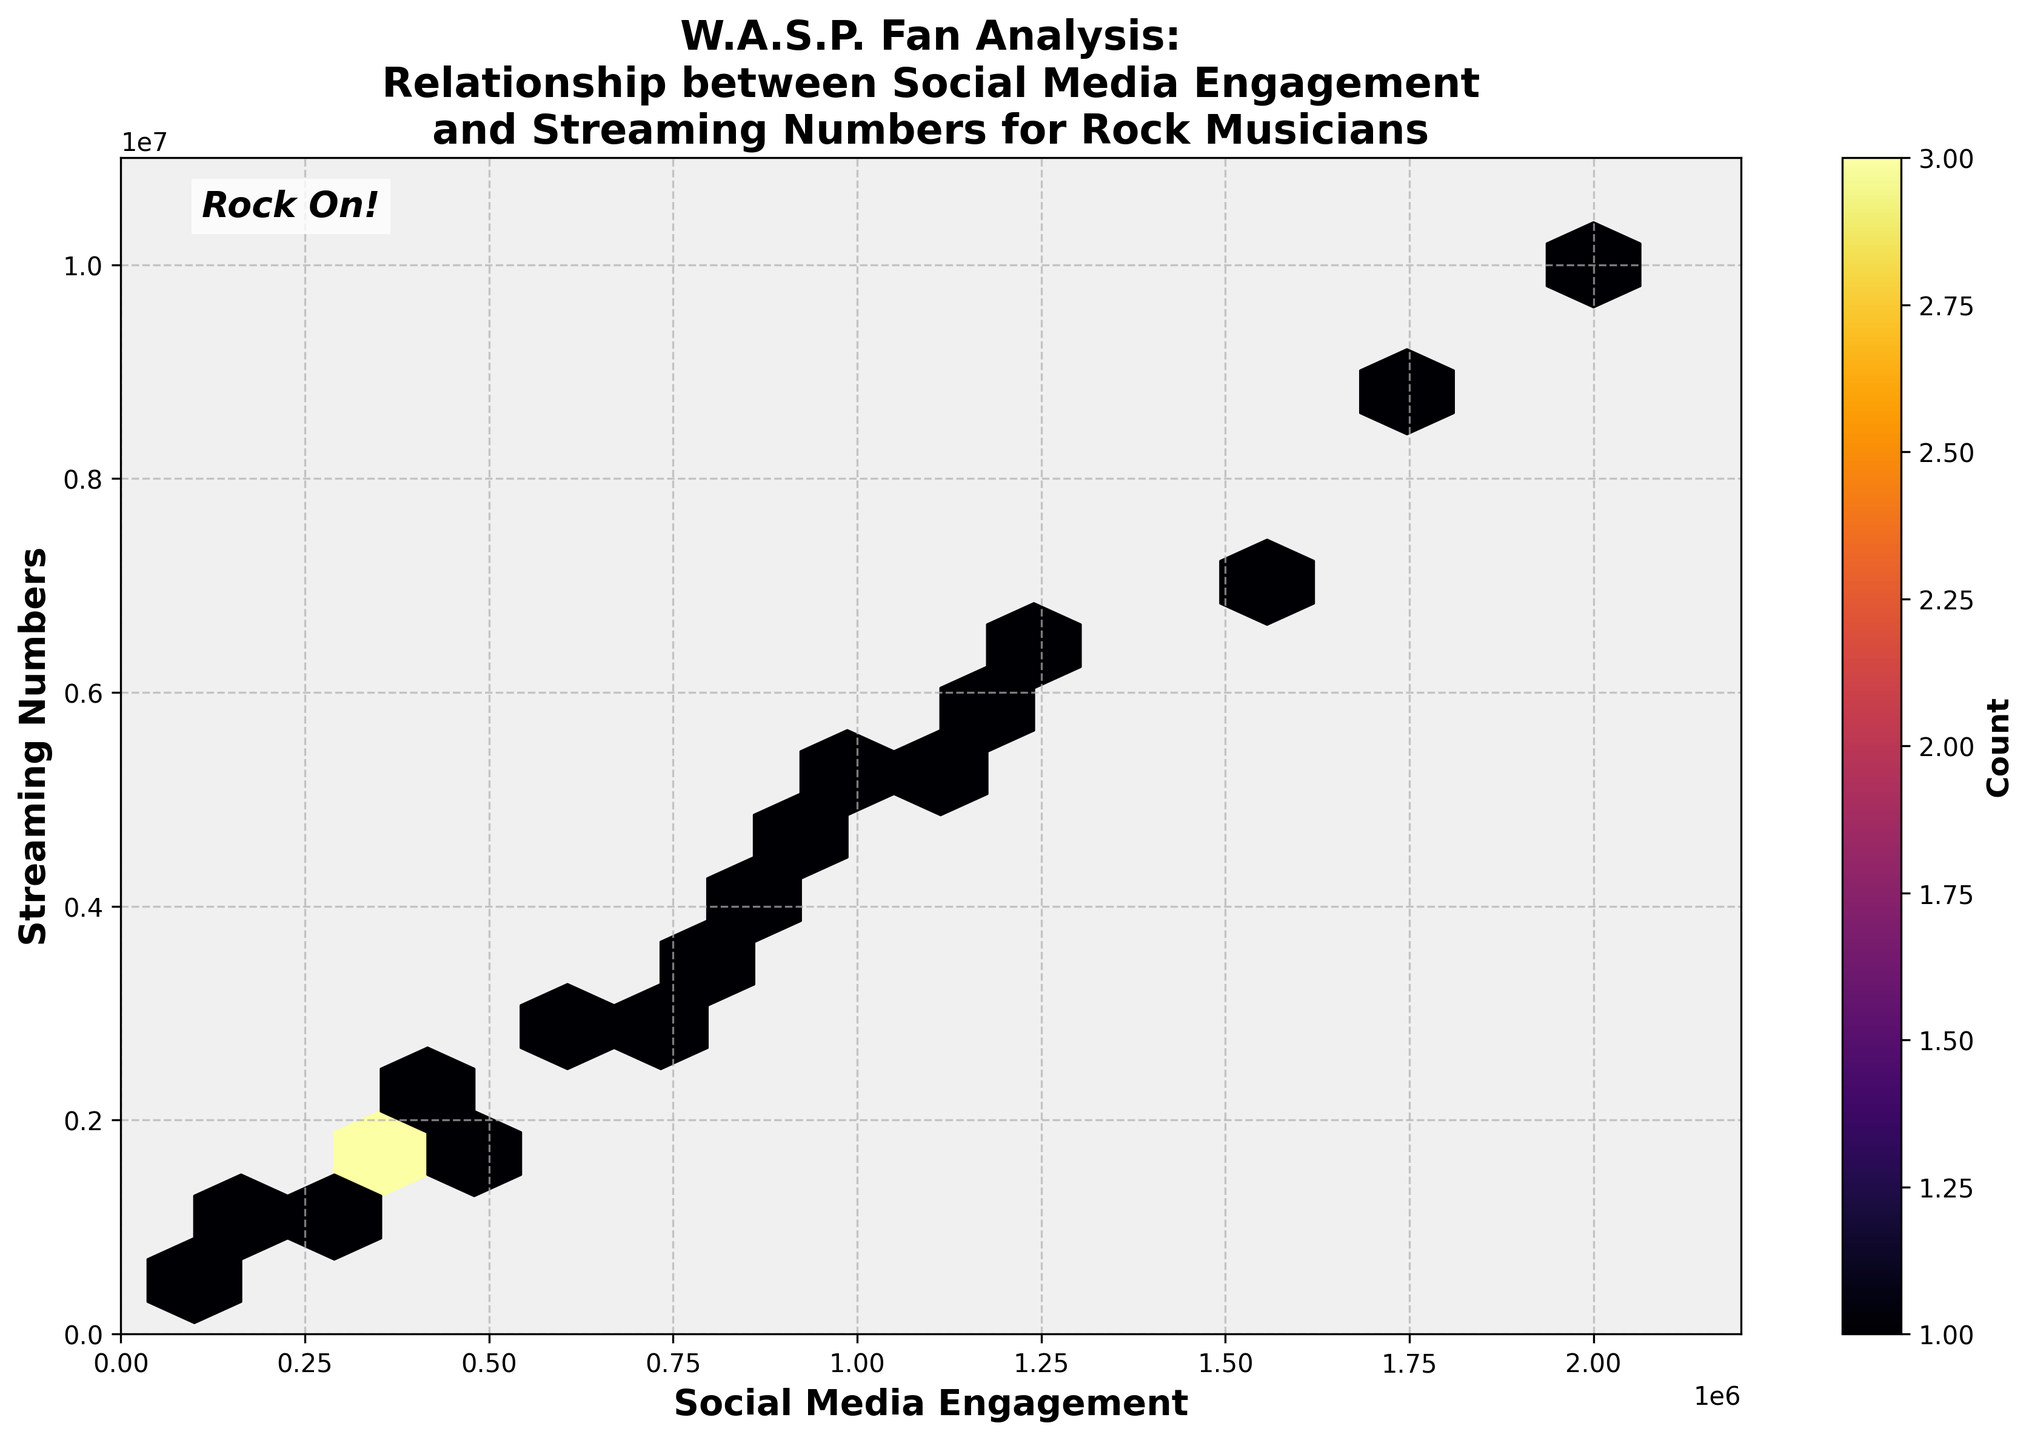What is the title of the figure? The title is located at the top of the figure and is visually distinctive because it is bolded and larger than other text elements.
Answer: 'W.A.S.P. Fan Analysis: Relationship between Social Media Engagement and Streaming Numbers for Rock Musicians' What does the color intensity represent in the Hexbin Plot? The color intensity in the Hexbin Plot represents the count or density of data points within each hexagonal bin. This is visually encoded by varying shades, with darker shades indicating higher density.
Answer: Count What range does the x-axis cover in this plot? The x-axis represents 'Social Media Engagement' and its range can be deduced by looking at the minimum and maximum ticks on the axis. The plot stretches a little beyond the highest value of social media engagement in the data to ensure no data point is clipped.
Answer: 0 to approximately 2.2 million How does an increase in social media engagement generally correlate with streaming numbers? Observing the overall trend in the plot, data points are more densely packed along a diagonal line from the bottom-left to the top-right, indicating that higher social media engagement is generally associated with higher streaming numbers.
Answer: Positive correlation What does the hexagonal bin located around 1,000,000 social media engagements and 5,000,000 streaming numbers suggest? This is identified by locating the bin and noting the shading. A darker bin indicates a higher frequency of data points around these values, suggesting many musicians have these levels of engagement and streaming.
Answer: High frequency What’s the relationship between the highest social media engagement and the highest streaming numbers? The highest values can be found by locating the extreme right and topmost parts of the x and y axes. These values generally form an upward trend, indicating that musicians with the highest social media engagement also tend to have the highest streaming numbers.
Answer: Both are high How many bins have the highest density of data points? This can be determined by counting the number of hexagonal bins with the darkest shading. Each hexagon represents a bin with a count of data points.
Answer: 1 Is there any noticeable pattern or cluster in the lower-left corner of the plot? This can be assessed by examining the density of lighter-shaded hexagons in the lower-left corner of the plot. A lower density indicates fewer data points in this region.
Answer: Low density Which specific social media engagement value has a significantly higher streaming number compared to others? By examining the variations in data point density along the y-axis for a fixed x-axis value, outliers or significantly higher values can be identified.
Answer: 2 million 